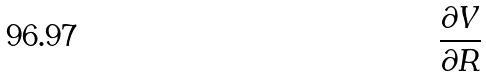<formula> <loc_0><loc_0><loc_500><loc_500>\frac { \partial V } { \partial R }</formula> 